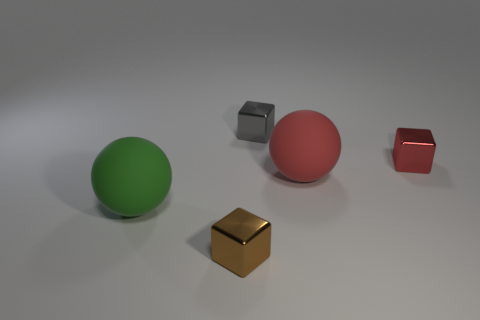Do the big object on the right side of the gray thing and the small cube to the right of the red rubber thing have the same color?
Offer a very short reply. Yes. There is a shiny thing that is left of the big red thing and behind the tiny brown object; what shape is it?
Provide a succinct answer. Cube. Are there an equal number of gray metallic things on the left side of the small gray metallic thing and big yellow spheres?
Your answer should be very brief. Yes. How many objects are large matte things or shiny cubes that are behind the tiny brown cube?
Provide a succinct answer. 4. Is there a yellow matte object of the same shape as the green matte object?
Give a very brief answer. No. Are there an equal number of tiny gray shiny cubes that are left of the tiny brown shiny object and small brown blocks that are behind the large red ball?
Ensure brevity in your answer.  Yes. Is there any other thing that has the same size as the red matte sphere?
Your answer should be very brief. Yes. What number of red objects are either small shiny things or tiny matte cylinders?
Give a very brief answer. 1. What number of red balls have the same size as the red shiny block?
Provide a succinct answer. 0. What is the color of the object that is both to the left of the tiny gray metallic cube and on the right side of the big green matte object?
Your answer should be compact. Brown. 